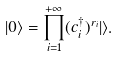<formula> <loc_0><loc_0><loc_500><loc_500>| 0 \rangle = \prod _ { i = 1 } ^ { + \infty } ( c ^ { \dagger } _ { i } ) ^ { r _ { i } } | \rangle .</formula> 